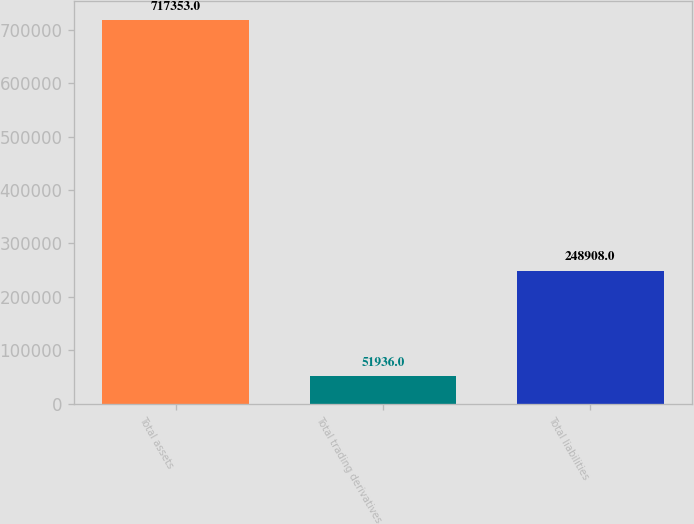Convert chart. <chart><loc_0><loc_0><loc_500><loc_500><bar_chart><fcel>Total assets<fcel>Total trading derivatives<fcel>Total liabilities<nl><fcel>717353<fcel>51936<fcel>248908<nl></chart> 